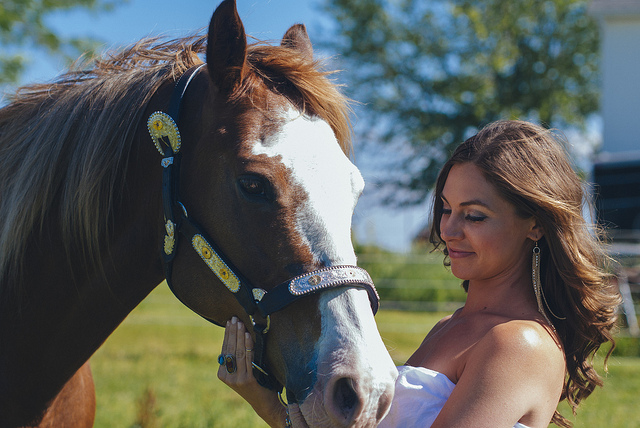<image>What type of tattoo is shown? There is no tattoo shown in the image. What type of tattoo is shown? There is no tattoo shown in the image. 